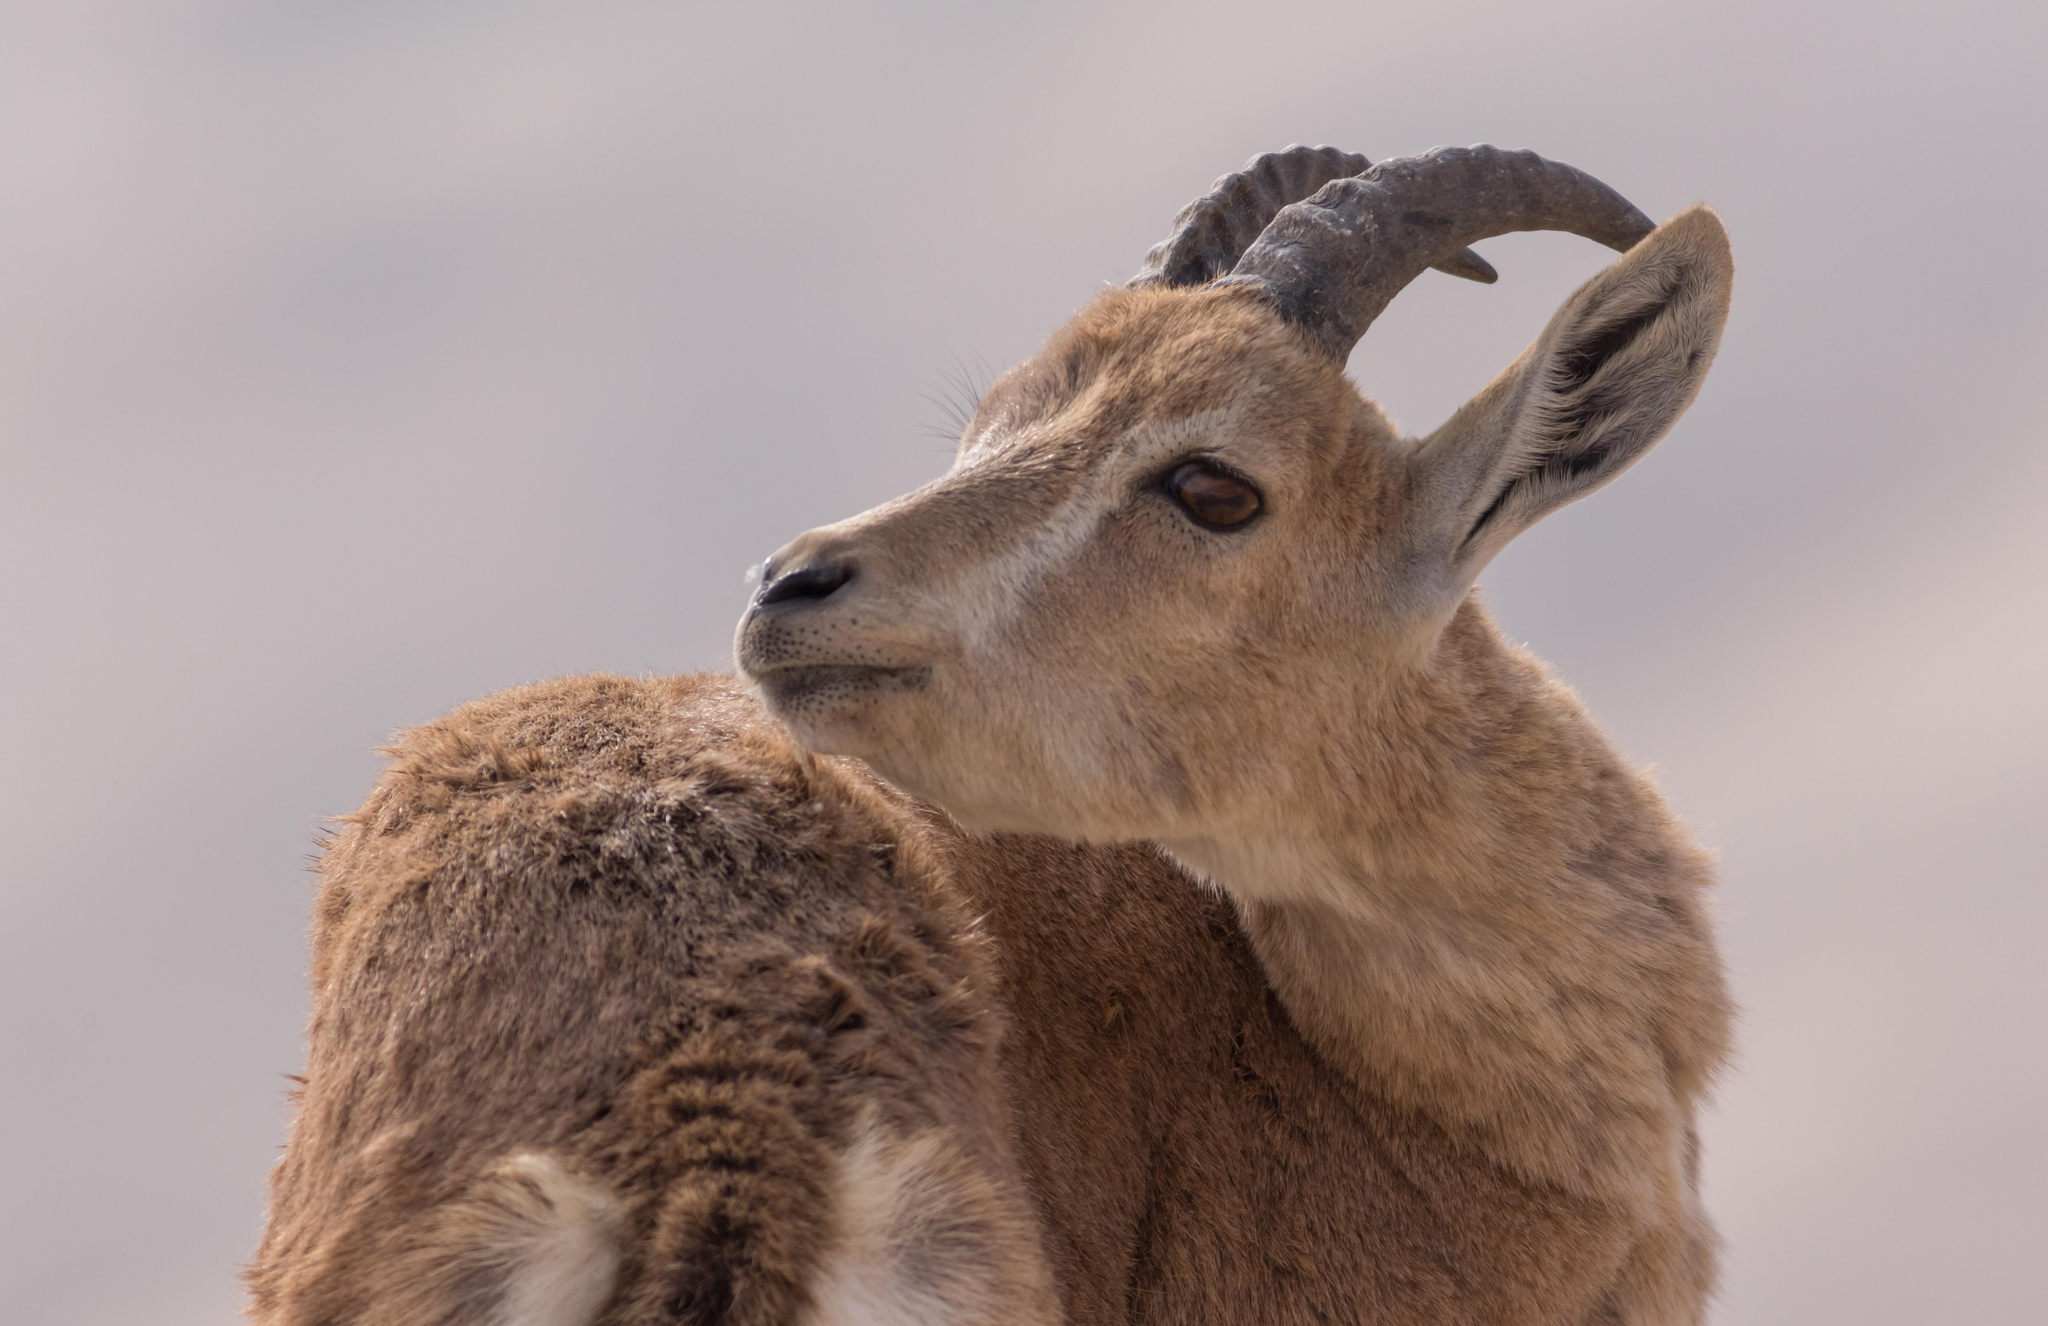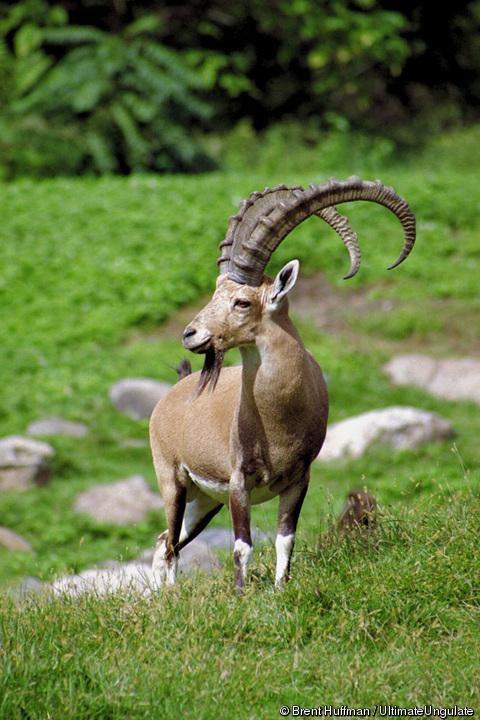The first image is the image on the left, the second image is the image on the right. Considering the images on both sides, is "A goat in the right image is laying down." valid? Answer yes or no. No. The first image is the image on the left, the second image is the image on the right. Assess this claim about the two images: "Each image contains only one horned animal, and one image shows an animal with long curled horns, while the other shows an animal with much shorter horns.". Correct or not? Answer yes or no. Yes. 